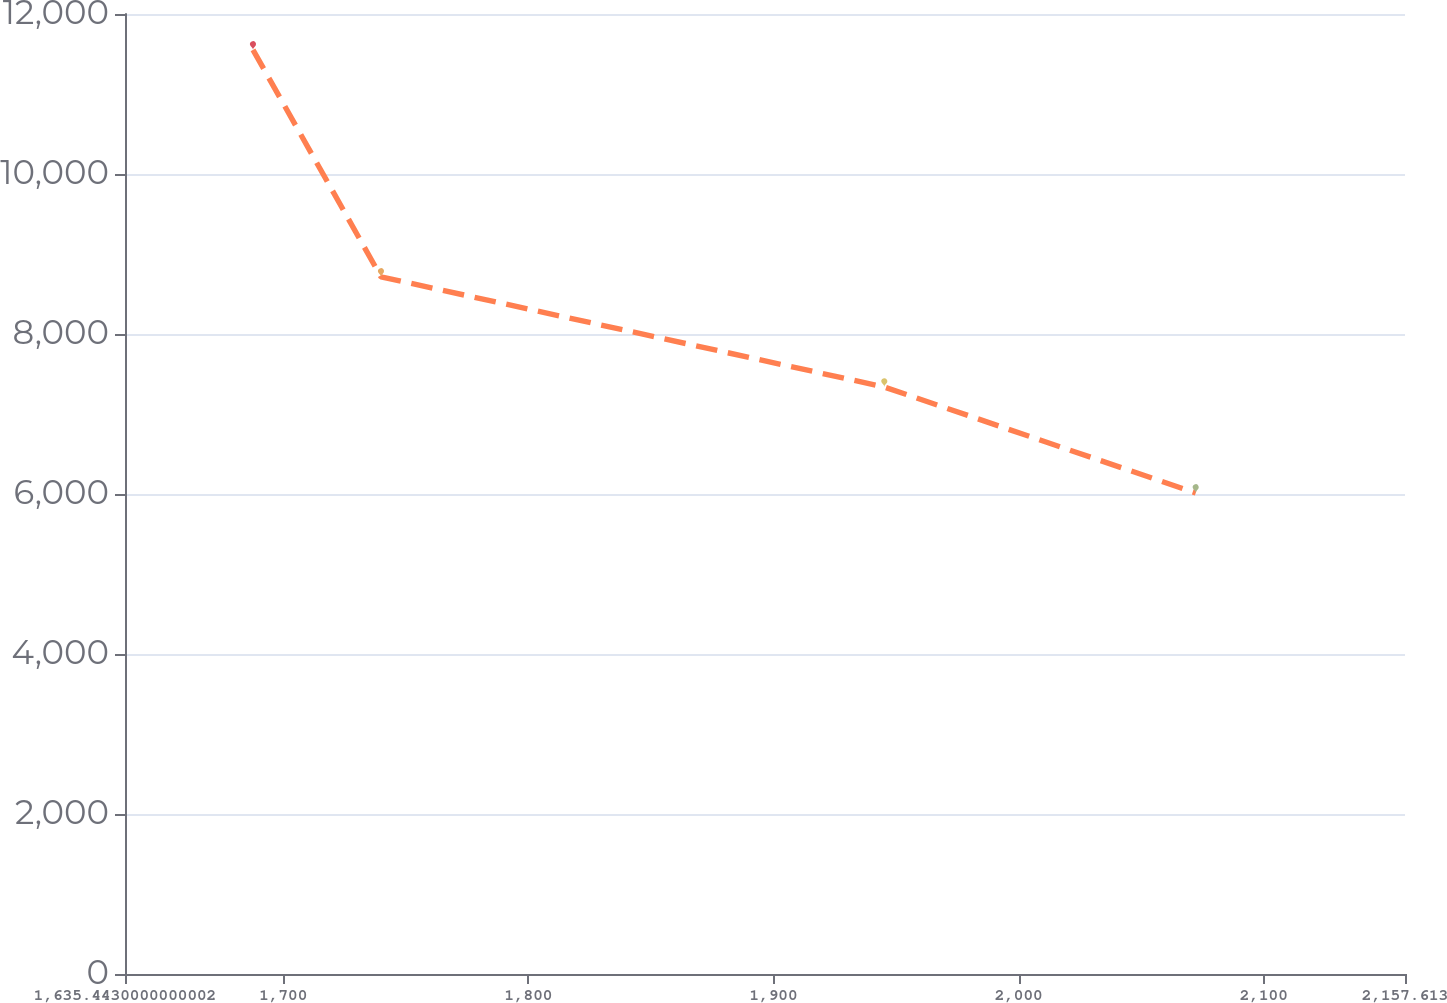<chart> <loc_0><loc_0><loc_500><loc_500><line_chart><ecel><fcel>Unnamed: 1<nl><fcel>1687.66<fcel>11552<nl><fcel>1739.88<fcel>8714.85<nl><fcel>1945.22<fcel>7337.22<nl><fcel>2072.25<fcel>6013.12<nl><fcel>2209.83<fcel>3893.54<nl></chart> 